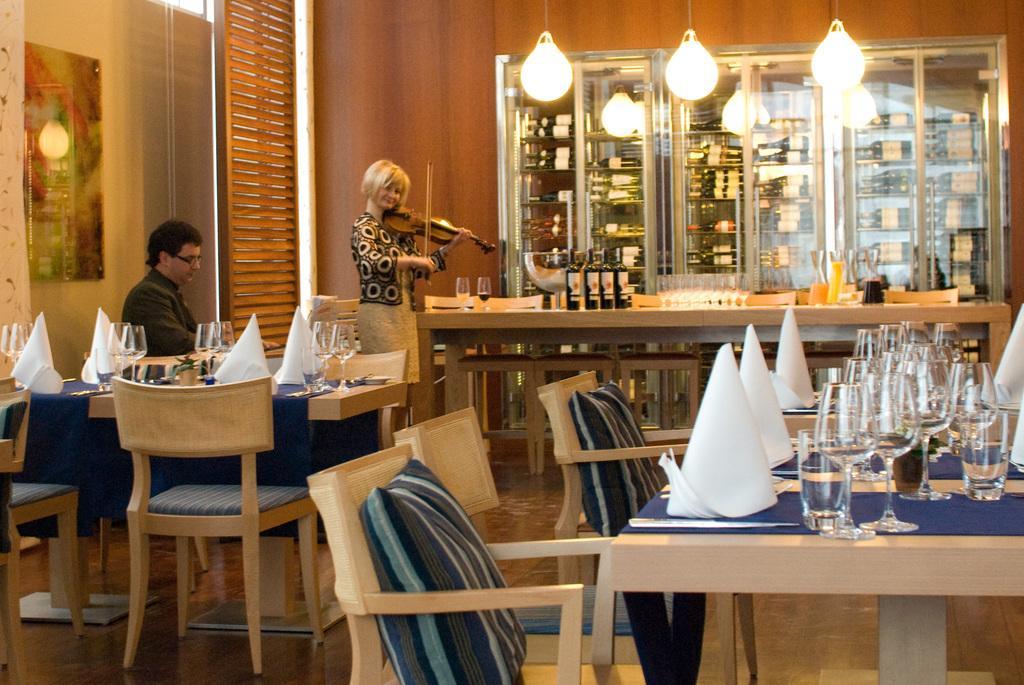In one or two sentences, can you explain what this image depicts? there are dining tables in a room on which there are blue clothes. on the tables there are glasses and white napkins. there are chairs around the tables on which there are cushions. at the left a person is sitting wearing a suit. behind him a person is standing playing violin. at the back there is a table on which there are black glass bottles and glasses. at the back there are shelves in which there are bottles. on the top there are lights. 